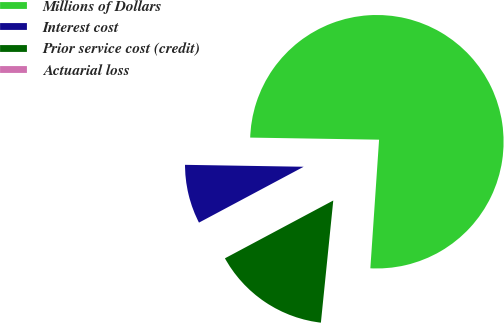<chart> <loc_0><loc_0><loc_500><loc_500><pie_chart><fcel>Millions of Dollars<fcel>Interest cost<fcel>Prior service cost (credit)<fcel>Actuarial loss<nl><fcel>75.82%<fcel>8.06%<fcel>15.59%<fcel>0.53%<nl></chart> 